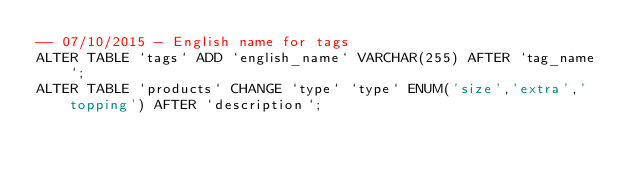Convert code to text. <code><loc_0><loc_0><loc_500><loc_500><_SQL_>-- 07/10/2015 - English name for tags
ALTER TABLE `tags` ADD `english_name` VARCHAR(255) AFTER `tag_name`;
ALTER TABLE `products` CHANGE `type` `type` ENUM('size','extra','topping') AFTER `description`;</code> 